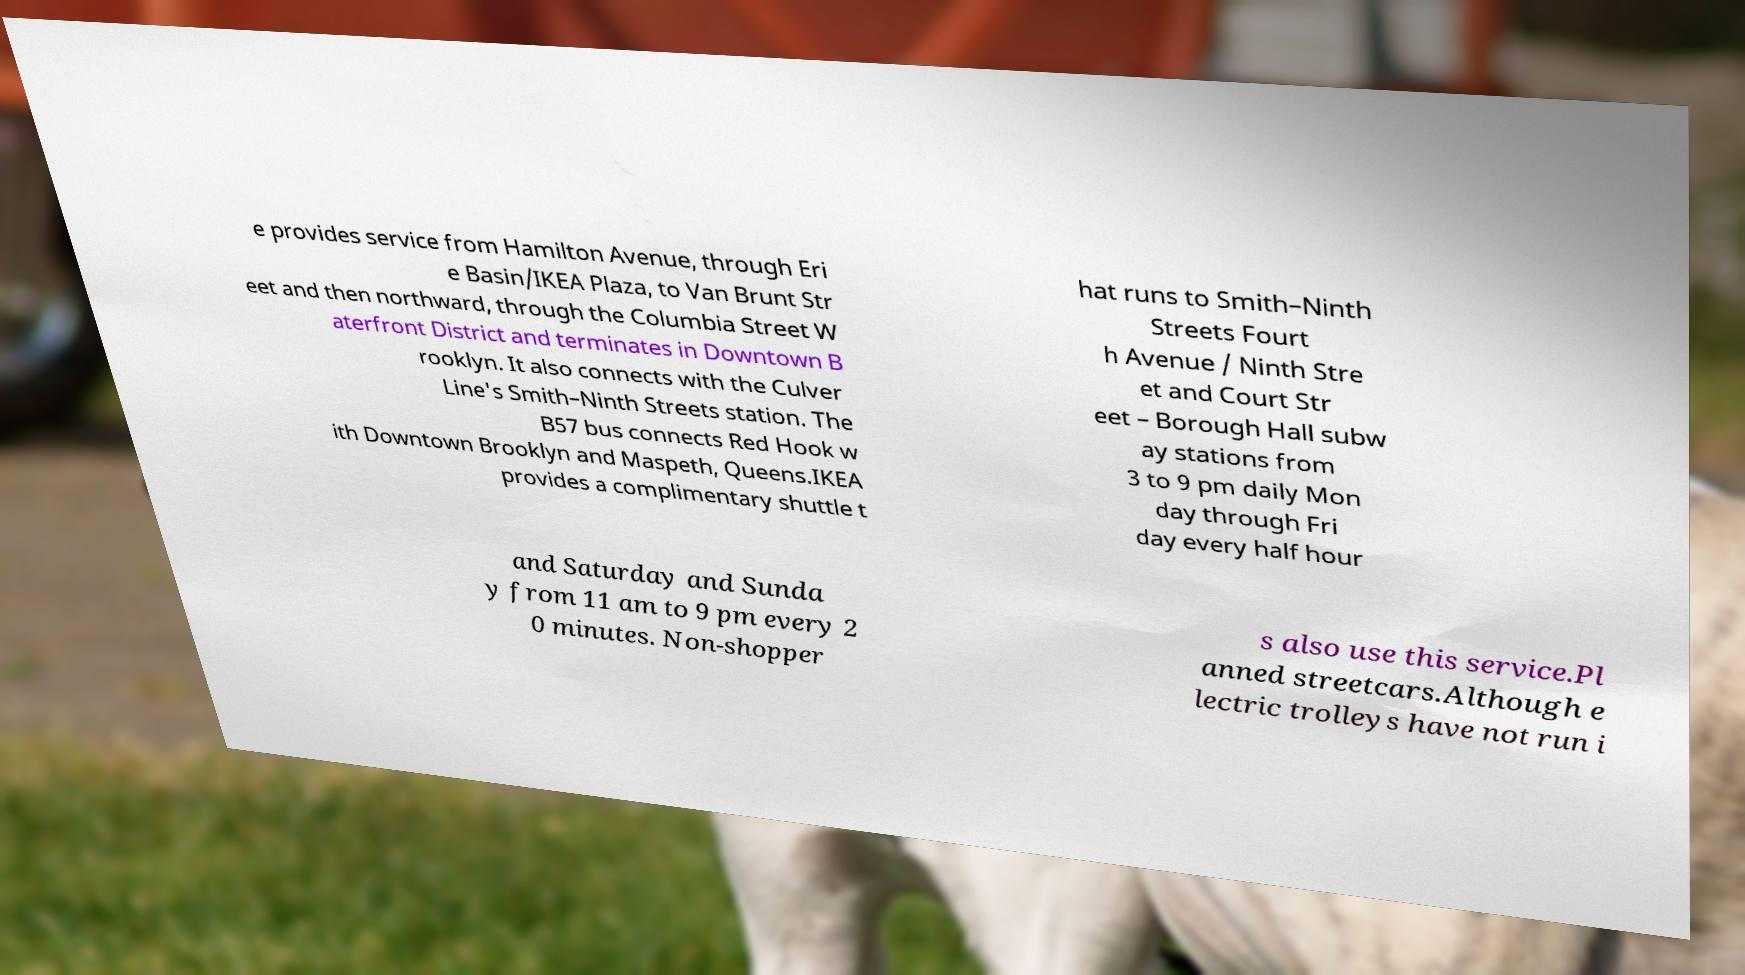Please identify and transcribe the text found in this image. e provides service from Hamilton Avenue, through Eri e Basin/IKEA Plaza, to Van Brunt Str eet and then northward, through the Columbia Street W aterfront District and terminates in Downtown B rooklyn. It also connects with the Culver Line's Smith–Ninth Streets station. The B57 bus connects Red Hook w ith Downtown Brooklyn and Maspeth, Queens.IKEA provides a complimentary shuttle t hat runs to Smith–Ninth Streets Fourt h Avenue / Ninth Stre et and Court Str eet – Borough Hall subw ay stations from 3 to 9 pm daily Mon day through Fri day every half hour and Saturday and Sunda y from 11 am to 9 pm every 2 0 minutes. Non-shopper s also use this service.Pl anned streetcars.Although e lectric trolleys have not run i 